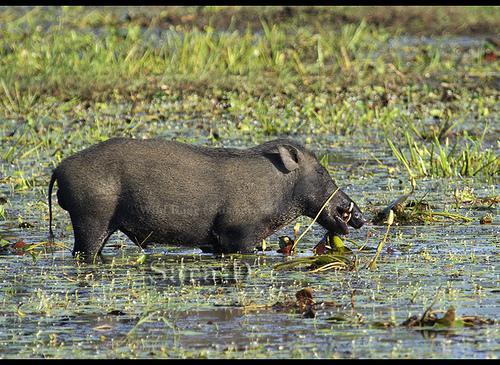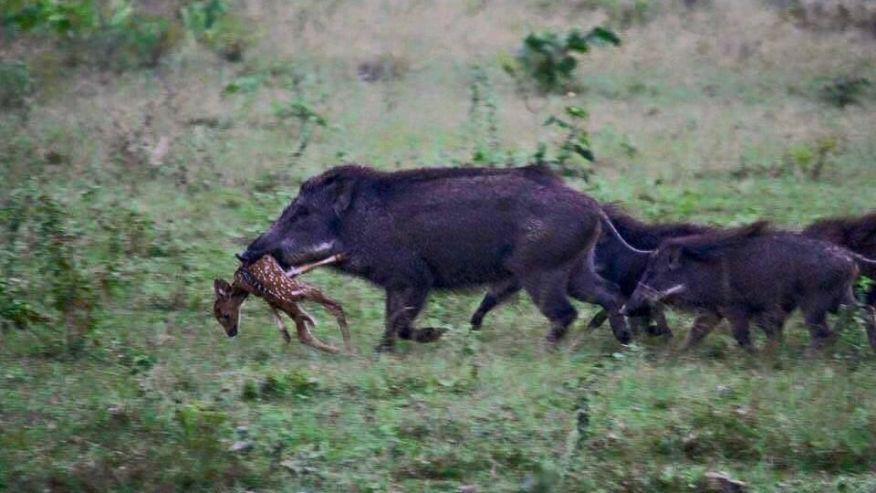The first image is the image on the left, the second image is the image on the right. For the images shown, is this caption "a hog is standing in water." true? Answer yes or no. Yes. The first image is the image on the left, the second image is the image on the right. Assess this claim about the two images: "An image shows a boar with its spotted deer-like prey animal.". Correct or not? Answer yes or no. Yes. 